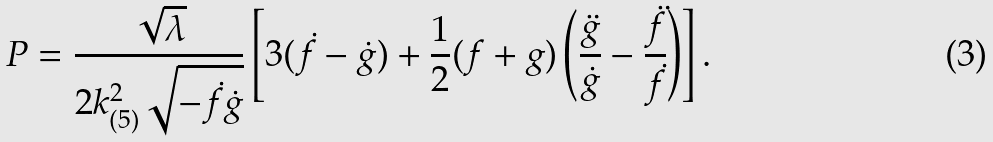Convert formula to latex. <formula><loc_0><loc_0><loc_500><loc_500>P = \frac { \sqrt { \lambda } } { 2 k _ { ( 5 ) } ^ { 2 } \sqrt { - \dot { f } \dot { g } } } \left [ 3 ( \dot { f } - \dot { g } ) + \frac { 1 } { 2 } ( f + g ) \left ( \frac { \ddot { g } } { \dot { g } } - \frac { \ddot { f } } { \dot { f } } \right ) \right ] .</formula> 